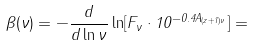Convert formula to latex. <formula><loc_0><loc_0><loc_500><loc_500>\beta ( \nu ) = - \frac { d } { d \ln \nu } \ln [ F _ { \nu } \cdot 1 0 ^ { - 0 . 4 A _ { ( z + 1 ) \nu } } ] =</formula> 